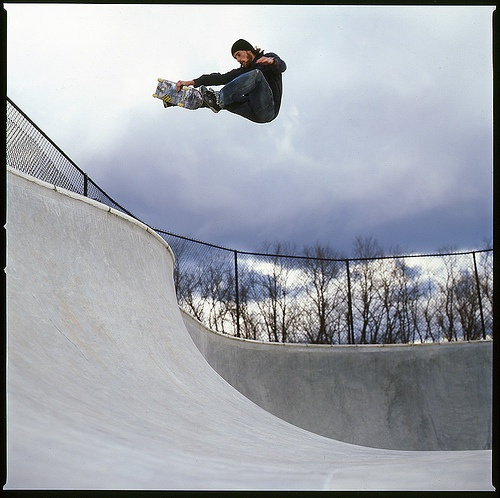Describe the objects in this image and their specific colors. I can see people in black, gray, white, and brown tones and skateboard in black, gray, and darkgray tones in this image. 